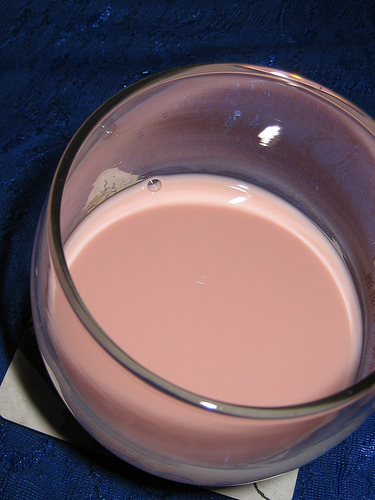<image>
Is there a chocolate milk in the drinking glass? Yes. The chocolate milk is contained within or inside the drinking glass, showing a containment relationship. 